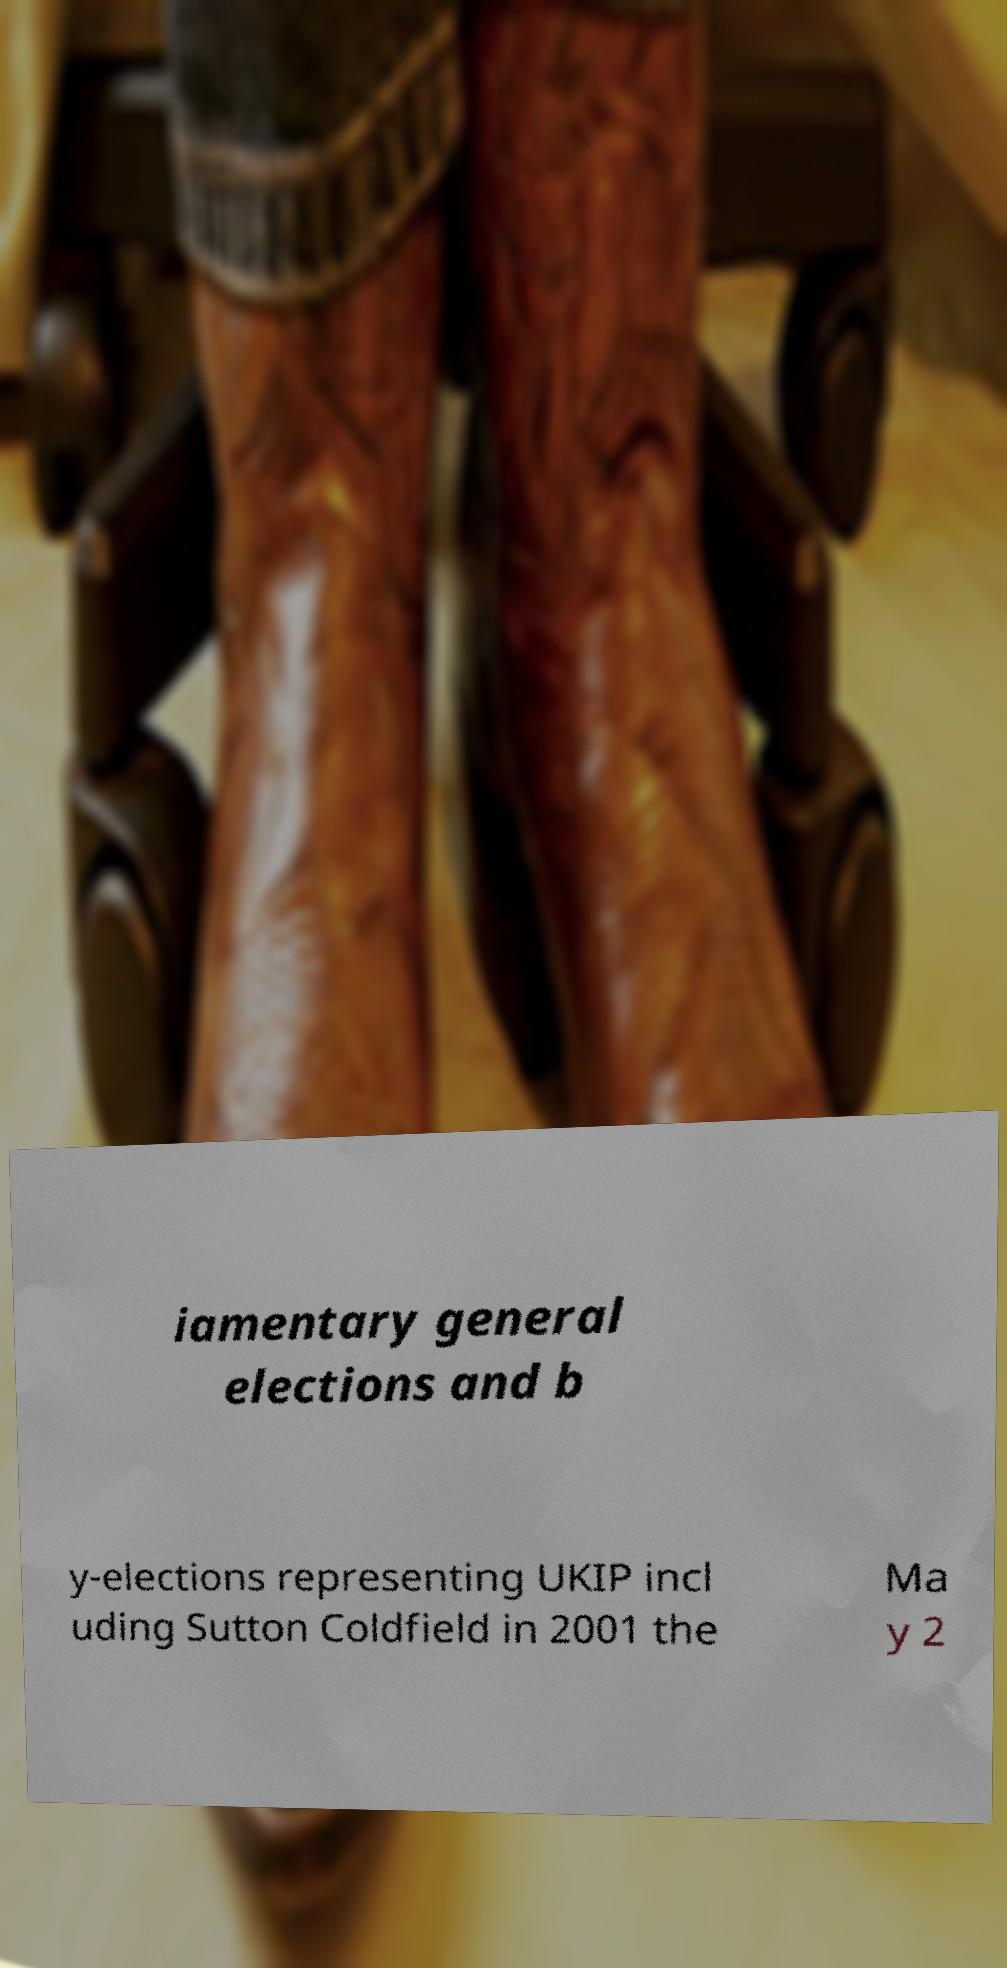Can you read and provide the text displayed in the image?This photo seems to have some interesting text. Can you extract and type it out for me? iamentary general elections and b y-elections representing UKIP incl uding Sutton Coldfield in 2001 the Ma y 2 